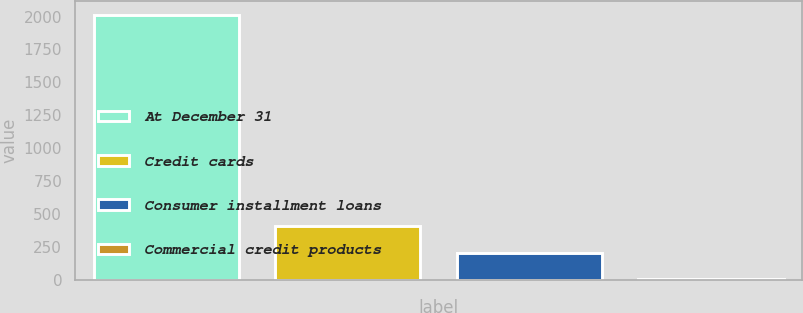<chart> <loc_0><loc_0><loc_500><loc_500><bar_chart><fcel>At December 31<fcel>Credit cards<fcel>Consumer installment loans<fcel>Commercial credit products<nl><fcel>2014<fcel>409.68<fcel>209.14<fcel>8.6<nl></chart> 